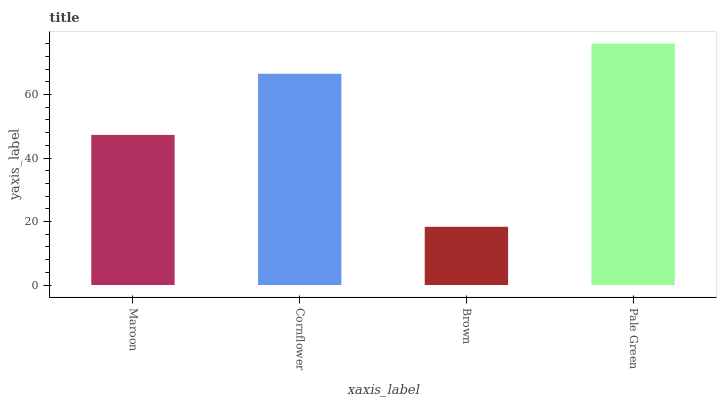Is Brown the minimum?
Answer yes or no. Yes. Is Pale Green the maximum?
Answer yes or no. Yes. Is Cornflower the minimum?
Answer yes or no. No. Is Cornflower the maximum?
Answer yes or no. No. Is Cornflower greater than Maroon?
Answer yes or no. Yes. Is Maroon less than Cornflower?
Answer yes or no. Yes. Is Maroon greater than Cornflower?
Answer yes or no. No. Is Cornflower less than Maroon?
Answer yes or no. No. Is Cornflower the high median?
Answer yes or no. Yes. Is Maroon the low median?
Answer yes or no. Yes. Is Pale Green the high median?
Answer yes or no. No. Is Cornflower the low median?
Answer yes or no. No. 